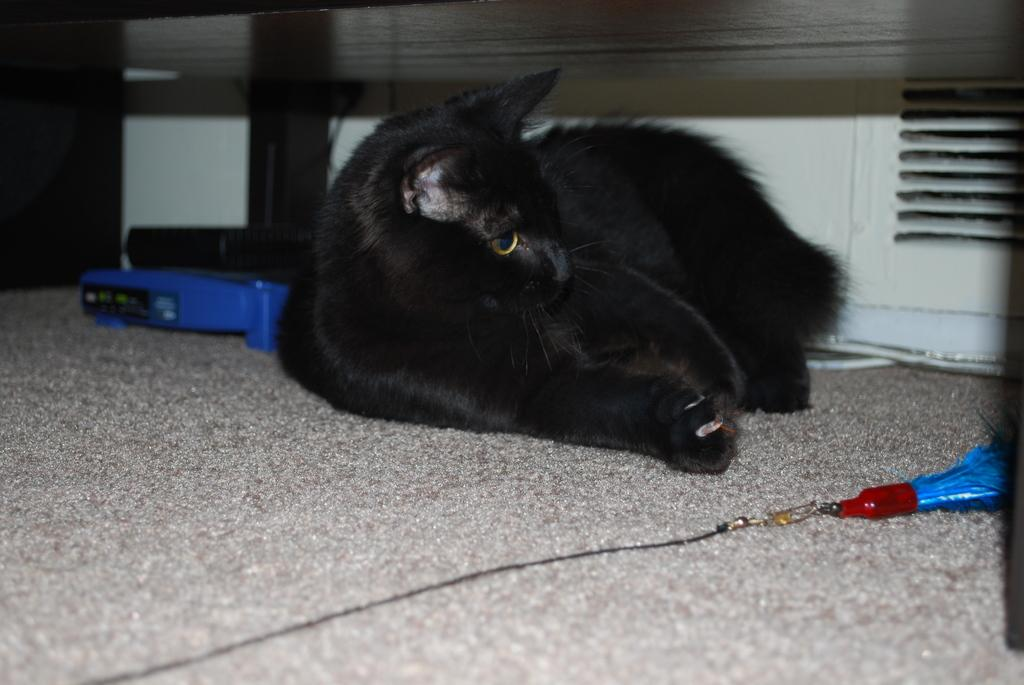What type of animal is laying in the image? There is a black color cat laying in the image. What is at the bottom of the image? There is a mat at the bottom of the image. What object can be seen on the right side of the image? There is a key chain on the right side of the image. What device is visible on the left side of the image? There appears to be a router on the left side of the image. What type of minister is present in the image? There is no minister present in the image; it features a black color cat, a mat, a key chain, and a router. How many angles can be seen in the image? There are no angles visible in the image; it is a flat representation of the scene. 